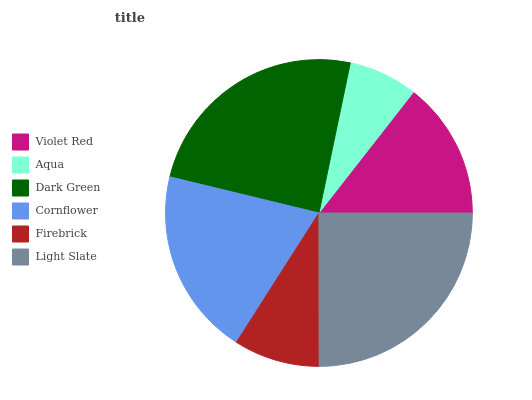Is Aqua the minimum?
Answer yes or no. Yes. Is Light Slate the maximum?
Answer yes or no. Yes. Is Dark Green the minimum?
Answer yes or no. No. Is Dark Green the maximum?
Answer yes or no. No. Is Dark Green greater than Aqua?
Answer yes or no. Yes. Is Aqua less than Dark Green?
Answer yes or no. Yes. Is Aqua greater than Dark Green?
Answer yes or no. No. Is Dark Green less than Aqua?
Answer yes or no. No. Is Cornflower the high median?
Answer yes or no. Yes. Is Violet Red the low median?
Answer yes or no. Yes. Is Violet Red the high median?
Answer yes or no. No. Is Light Slate the low median?
Answer yes or no. No. 